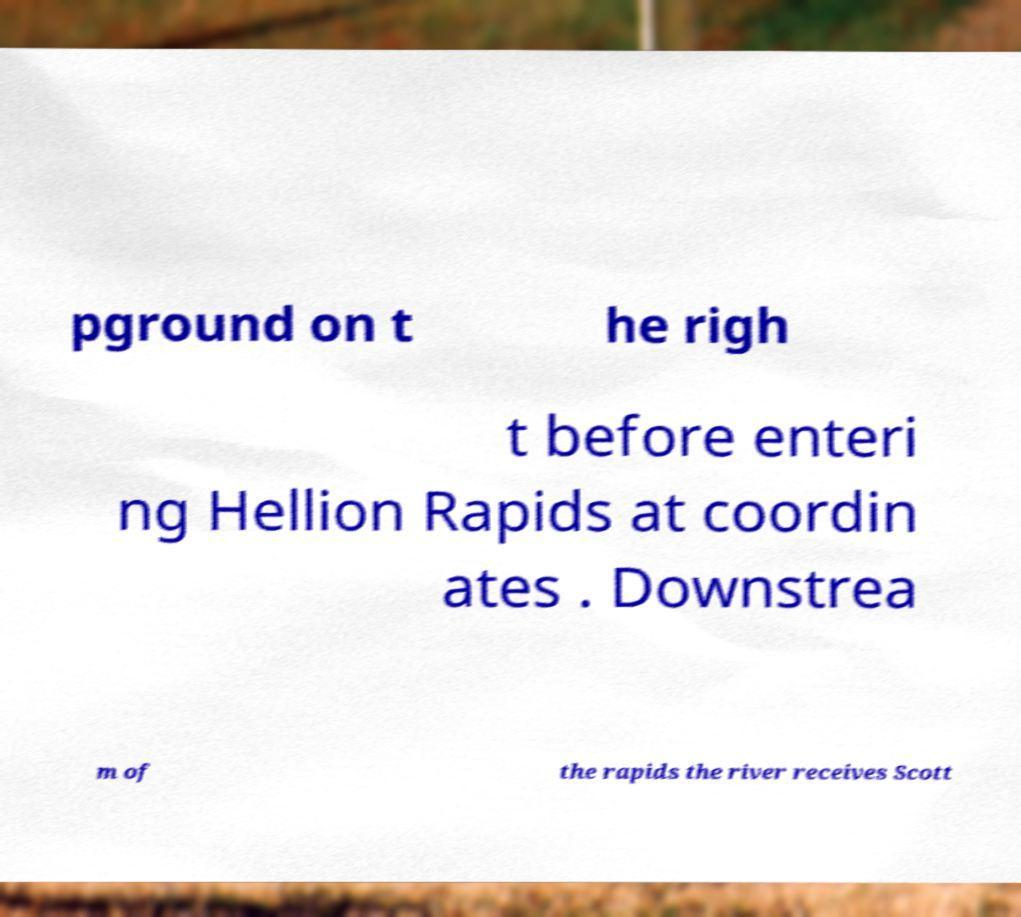For documentation purposes, I need the text within this image transcribed. Could you provide that? pground on t he righ t before enteri ng Hellion Rapids at coordin ates . Downstrea m of the rapids the river receives Scott 